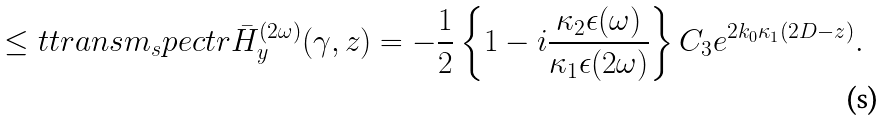Convert formula to latex. <formula><loc_0><loc_0><loc_500><loc_500>\leq t { t r a n s m _ { s } p e c t r } \bar { H } _ { y } ^ { ( 2 \omega ) } ( \gamma , z ) = - \frac { 1 } { 2 } \left \{ 1 - i \frac { \kappa _ { 2 } \epsilon ( \omega ) } { \kappa _ { 1 } \epsilon ( 2 \omega ) } \right \} C _ { 3 } e ^ { 2 k _ { 0 } \kappa _ { 1 } ( 2 D - z ) } .</formula> 